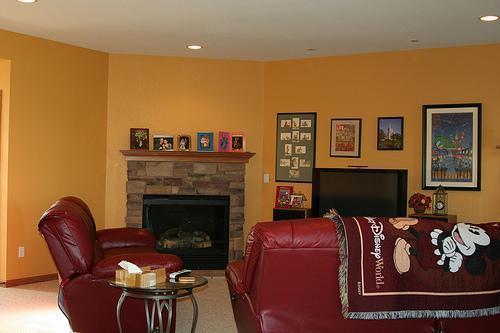How many sofas are there?
Give a very brief answer. 2. 